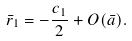<formula> <loc_0><loc_0><loc_500><loc_500>\bar { r } _ { 1 } = - \frac { c _ { 1 } } { 2 } + O ( \bar { a } ) .</formula> 